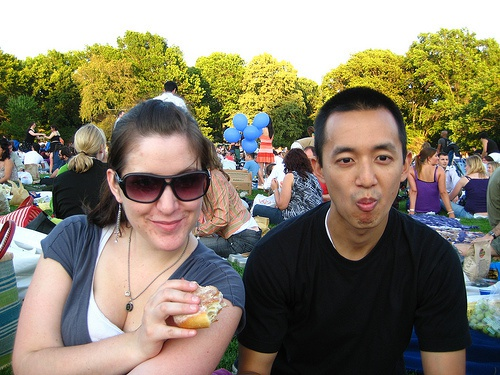Describe the objects in this image and their specific colors. I can see people in white, black, gray, tan, and brown tones, people in white, tan, lightgray, and gray tones, people in white, black, darkgray, and gray tones, people in white, lightpink, darkgray, gray, and tan tones, and people in white, black, darkgray, tan, and gray tones in this image. 